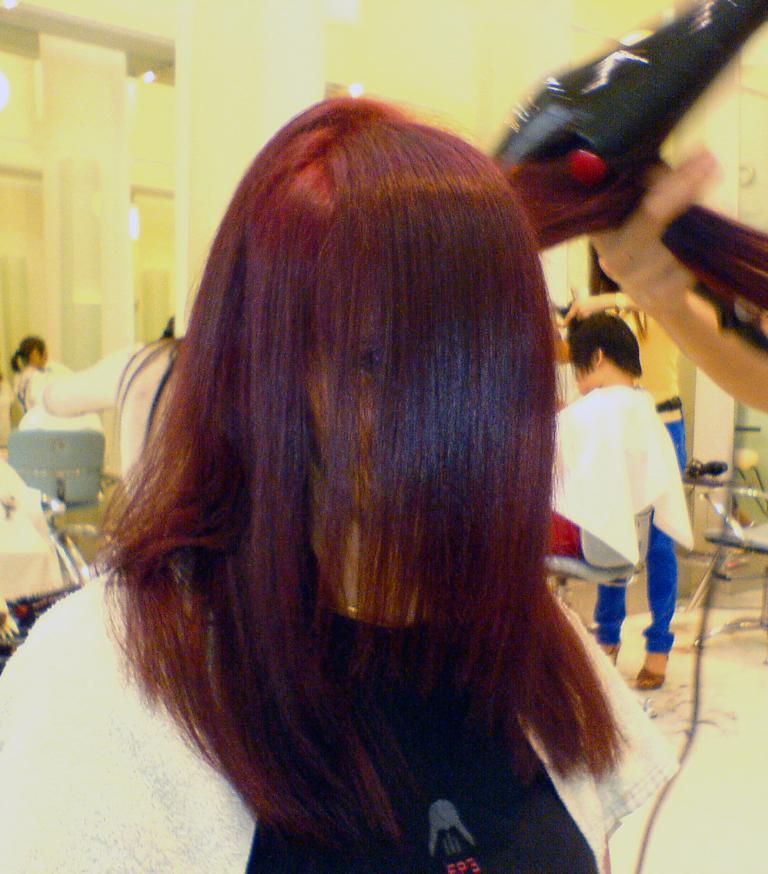Can you describe this image briefly? This image is taken in a salon. In this image we can see the people. In the center we can see a woman. On the right we can see a person holding the object. We can also see the pillows, lights and also the floor. We can see the people sitting on the chairs. 